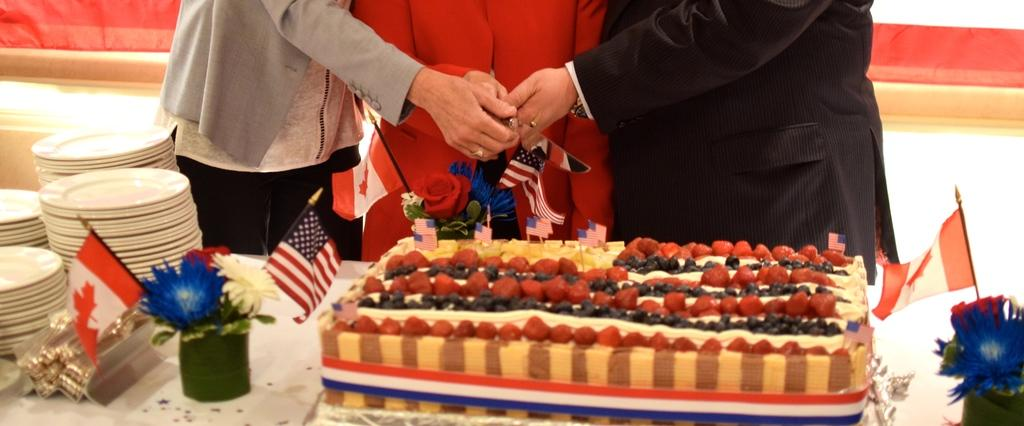What objects are on the table in the image? There are plants, flags, plates, and a cake with a rose on the table. What is the cake decorated with? The cake has a rose as a decoration. What are the people near the cake holding? Three people are holding knives near the cake. What type of insect can be seen crawling on the chin of one of the people in the image? There are no insects visible in the image, and no one's chin is shown. What type of magic trick is being performed by the person holding the cake knife? There is no magic trick being performed in the image; the people are simply holding knives near the cake. 